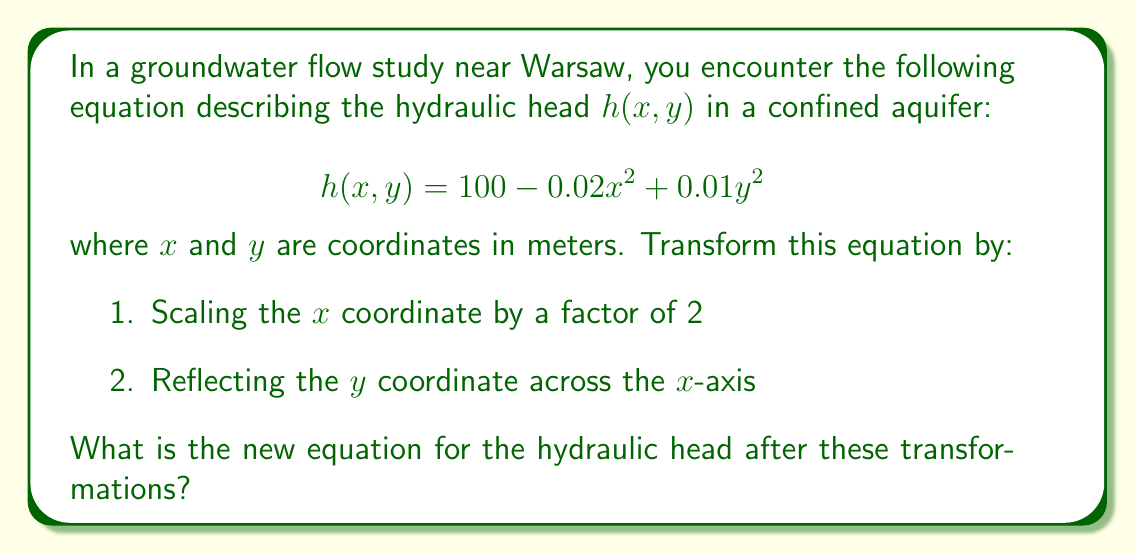Can you solve this math problem? Let's approach this step-by-step:

1) Scaling the $x$ coordinate by a factor of 2:
   This means we replace every $x$ with $\frac{x}{2}$ in the original equation.
   $$h(x,y) = 100 - 0.02(\frac{x}{2})^2 + 0.01y^2$$

2) Simplifying the $x$ term:
   $$h(x,y) = 100 - 0.02(\frac{x^2}{4}) + 0.01y^2$$
   $$h(x,y) = 100 - 0.005x^2 + 0.01y^2$$

3) Reflecting the $y$ coordinate across the $x$-axis:
   This means we replace every $y$ with $-y$ in the equation from step 2.
   $$h(x,y) = 100 - 0.005x^2 + 0.01(-y)^2$$

4) Simplifying the $y$ term:
   $$h(x,y) = 100 - 0.005x^2 + 0.01y^2$$

The final transformed equation is:
$$h(x,y) = 100 - 0.005x^2 + 0.01y^2$$
Answer: $h(x,y) = 100 - 0.005x^2 + 0.01y^2$ 